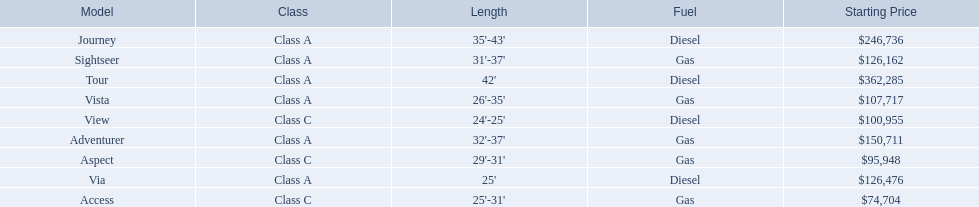What is the highest price of a winnebago model? $362,285. What is the name of the vehicle with this price? Tour. 